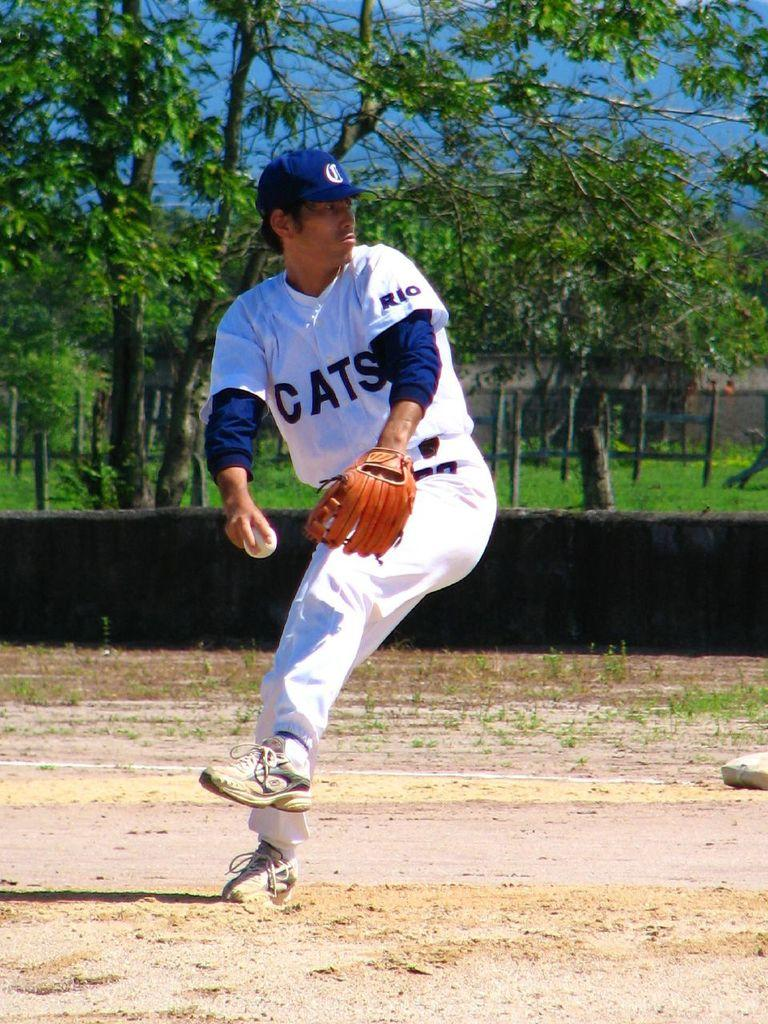<image>
Write a terse but informative summary of the picture. a man with the word cats on his jersey 